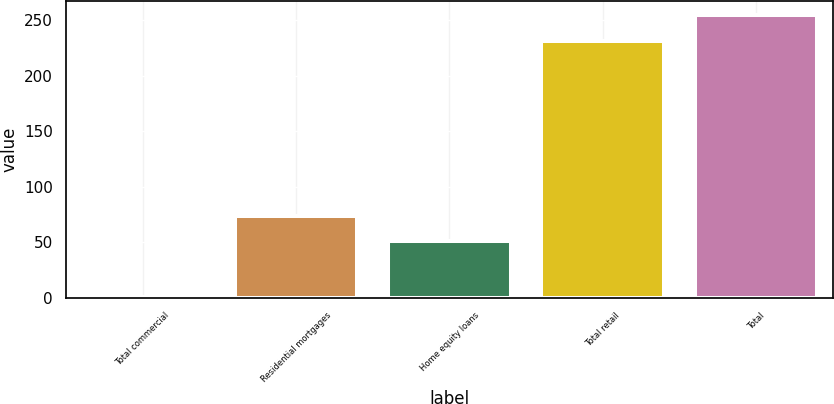<chart> <loc_0><loc_0><loc_500><loc_500><bar_chart><fcel>Total commercial<fcel>Residential mortgages<fcel>Home equity loans<fcel>Total retail<fcel>Total<nl><fcel>1<fcel>74.1<fcel>51<fcel>231<fcel>254.1<nl></chart> 